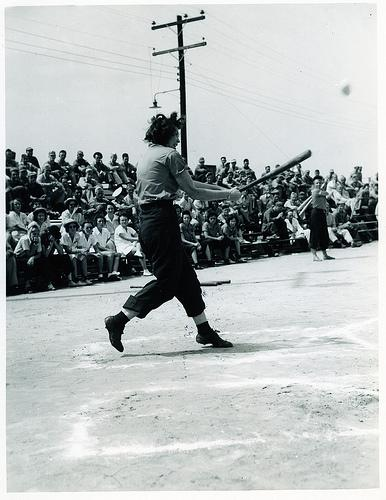Question: why are there spectators?
Choices:
A. There is a parade.
B. It is a recital.
C. It is a wrestling match.
D. It's a baseball game.
Answer with the letter. Answer: D Question: how is the ball positioned?
Choices:
A. In the air.
B. On the field.
C. In the glove.
D. On the grass.
Answer with the letter. Answer: A Question: what has wires coming off of it?
Choices:
A. Telephone pole.
B. The traffic light.
C. The telephone.
D. The fan.
Answer with the letter. Answer: A Question: where is the bat positioned?
Choices:
A. On the ground.
B. In front of the man.
C. Leaning on the wall.
D. On the counter.
Answer with the letter. Answer: B Question: where is there a light?
Choices:
A. From the ceiling.
B. From the window.
C. Coming off of the telephone pole.
D. From the end of the tunnel.
Answer with the letter. Answer: C 